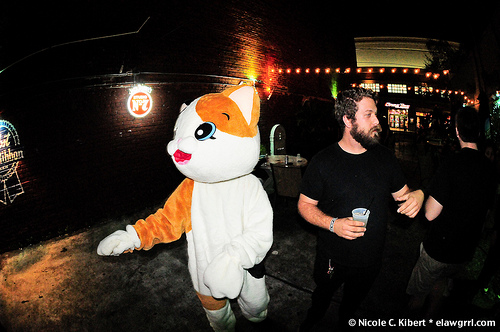<image>
Is there a cat behind the man? No. The cat is not behind the man. From this viewpoint, the cat appears to be positioned elsewhere in the scene. Is there a man in front of the bunny? No. The man is not in front of the bunny. The spatial positioning shows a different relationship between these objects. 